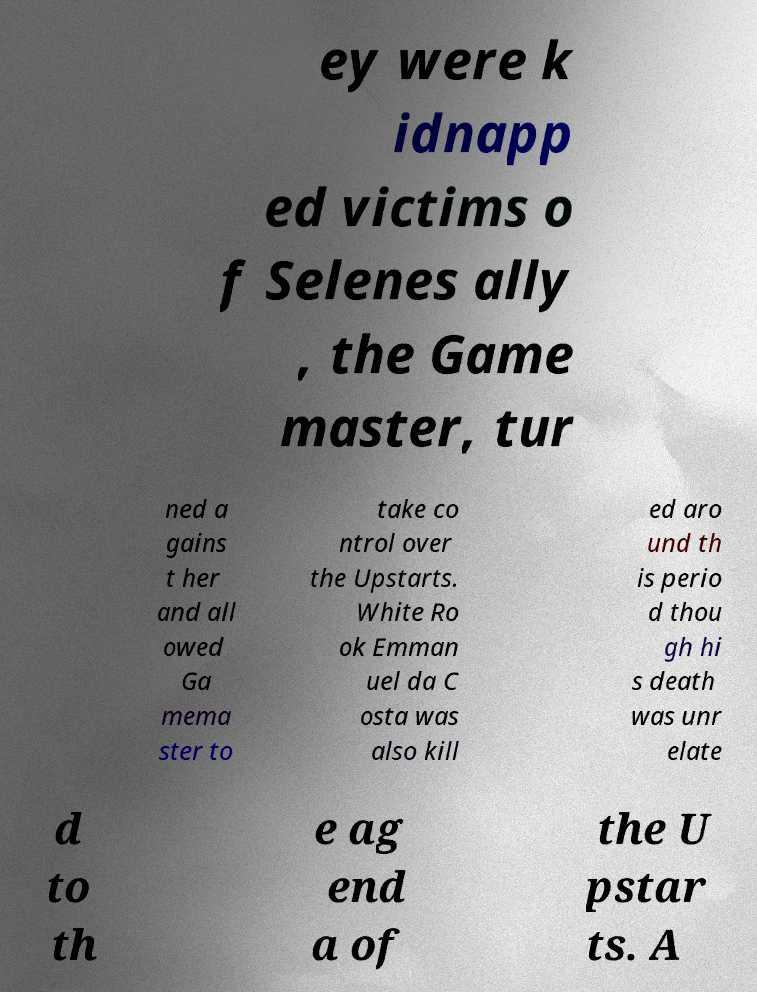Please read and relay the text visible in this image. What does it say? ey were k idnapp ed victims o f Selenes ally , the Game master, tur ned a gains t her and all owed Ga mema ster to take co ntrol over the Upstarts. White Ro ok Emman uel da C osta was also kill ed aro und th is perio d thou gh hi s death was unr elate d to th e ag end a of the U pstar ts. A 